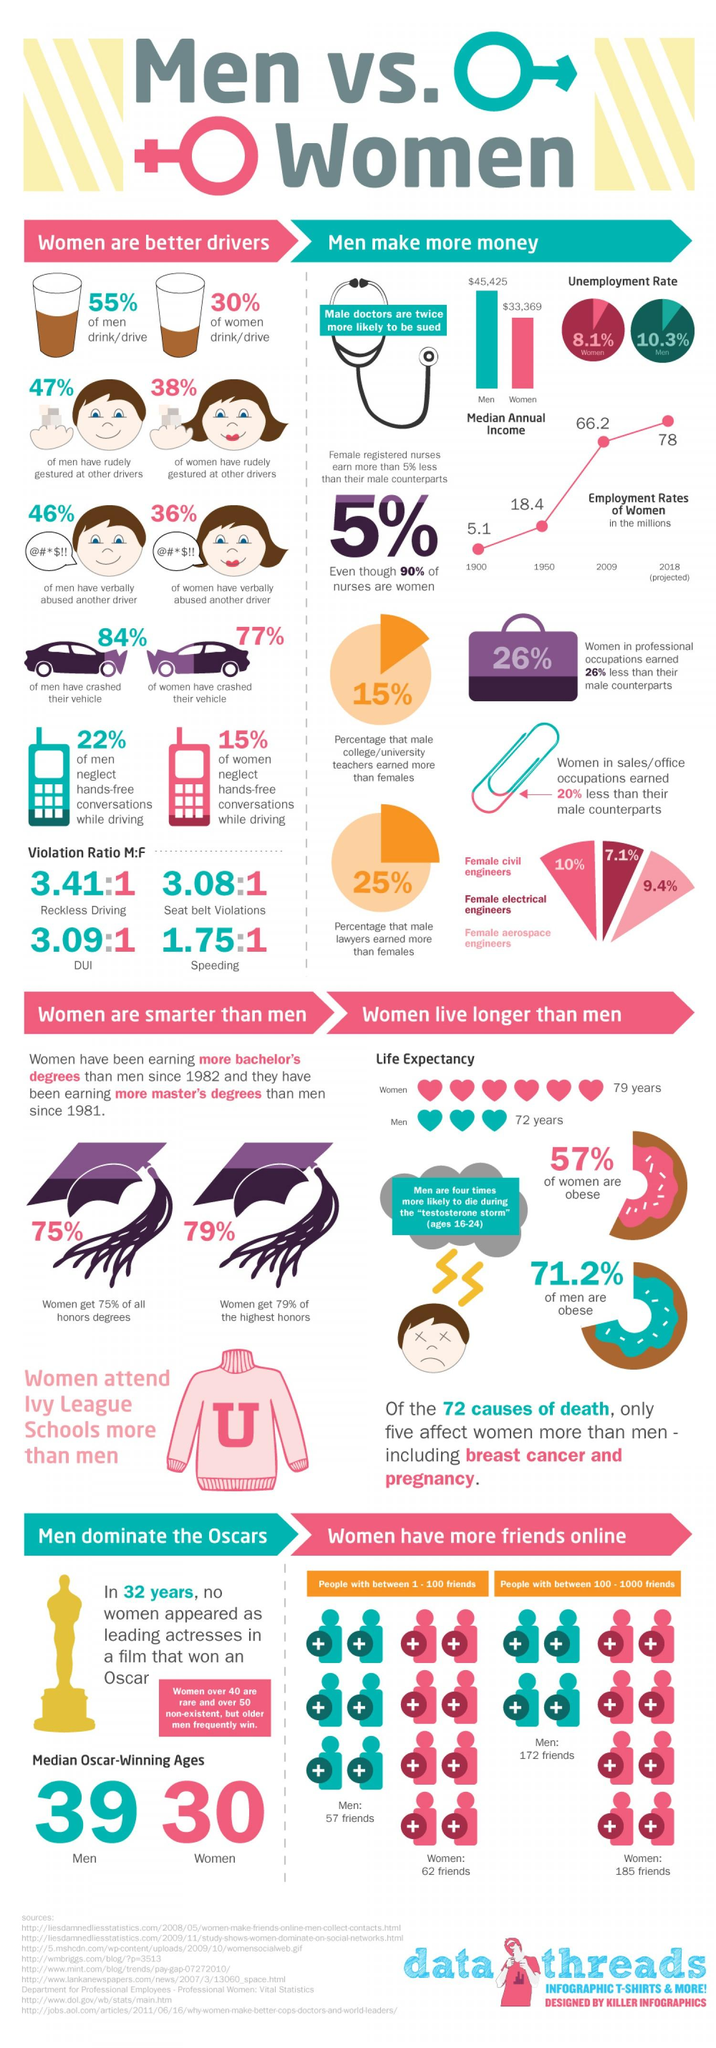Specify some key components in this picture. The lowest level of violation in men is typically represented by speeding. Electrical engineering has the lowest representation of women in percentage among the fields of civil engineering, electrical engineering, and aerospace engineering. The earnings of men in sales are 20% higher than women, with a range of 22% and 15% for these two respective percentages. The percentage of women aerospace engineers is 9.4%. 